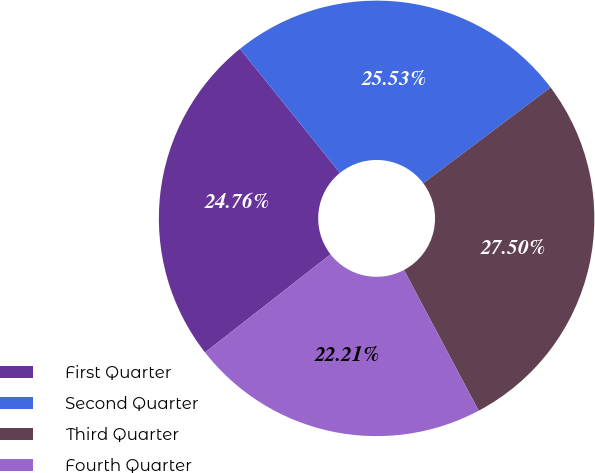Convert chart. <chart><loc_0><loc_0><loc_500><loc_500><pie_chart><fcel>First Quarter<fcel>Second Quarter<fcel>Third Quarter<fcel>Fourth Quarter<nl><fcel>24.76%<fcel>25.53%<fcel>27.5%<fcel>22.21%<nl></chart> 